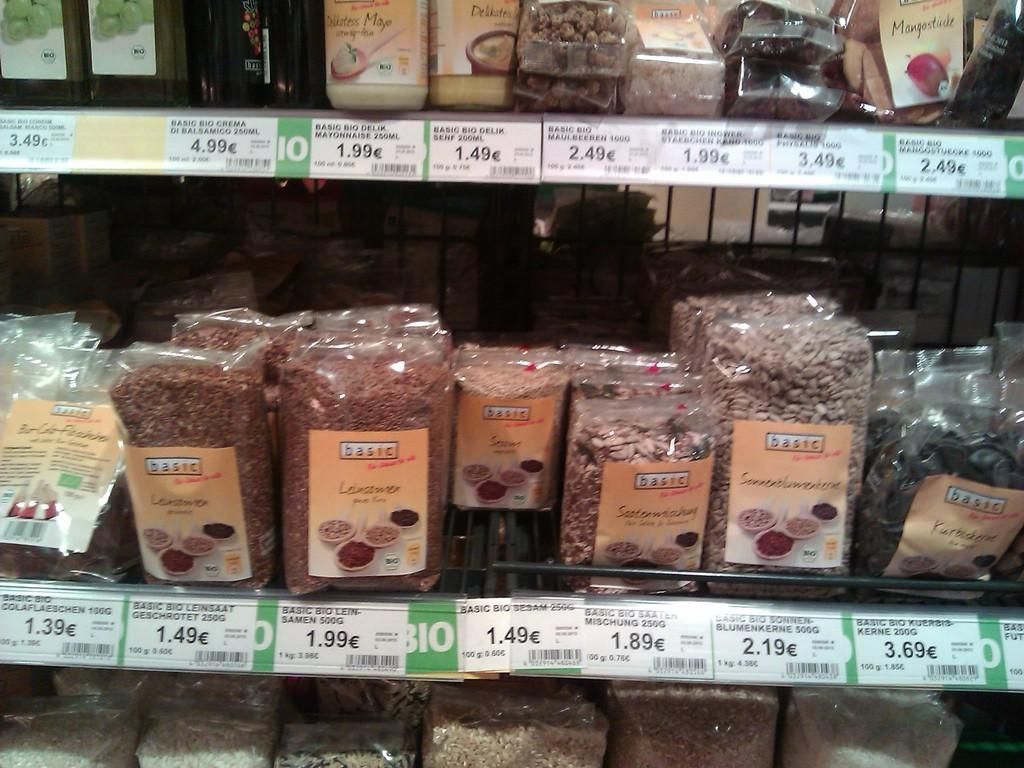<image>
Give a short and clear explanation of the subsequent image. A shelf in a store has various items with the prices like 1.39 and 1.49 visible. 